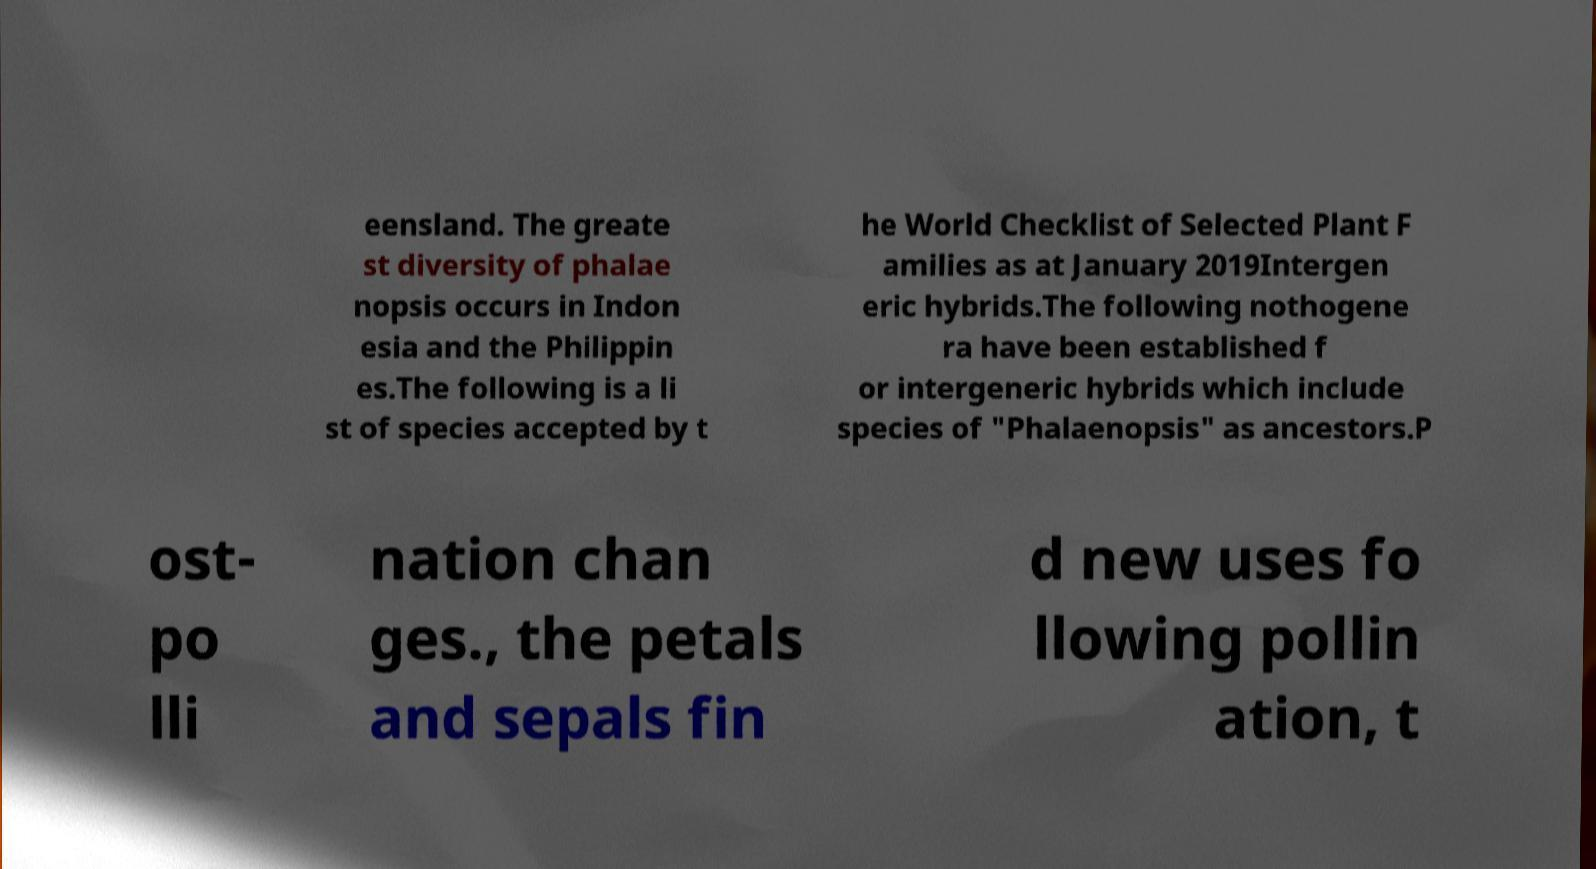Please identify and transcribe the text found in this image. eensland. The greate st diversity of phalae nopsis occurs in Indon esia and the Philippin es.The following is a li st of species accepted by t he World Checklist of Selected Plant F amilies as at January 2019Intergen eric hybrids.The following nothogene ra have been established f or intergeneric hybrids which include species of "Phalaenopsis" as ancestors.P ost- po lli nation chan ges., the petals and sepals fin d new uses fo llowing pollin ation, t 